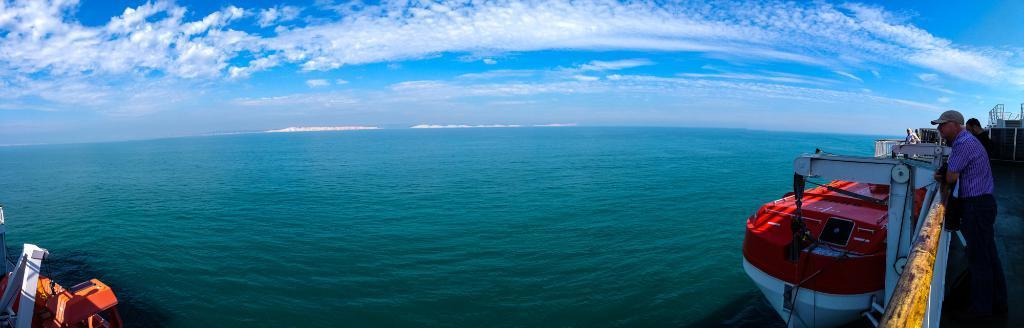Please provide a concise description of this image. In this image we can see persons standing on the ship, ocean and sky with clouds. 